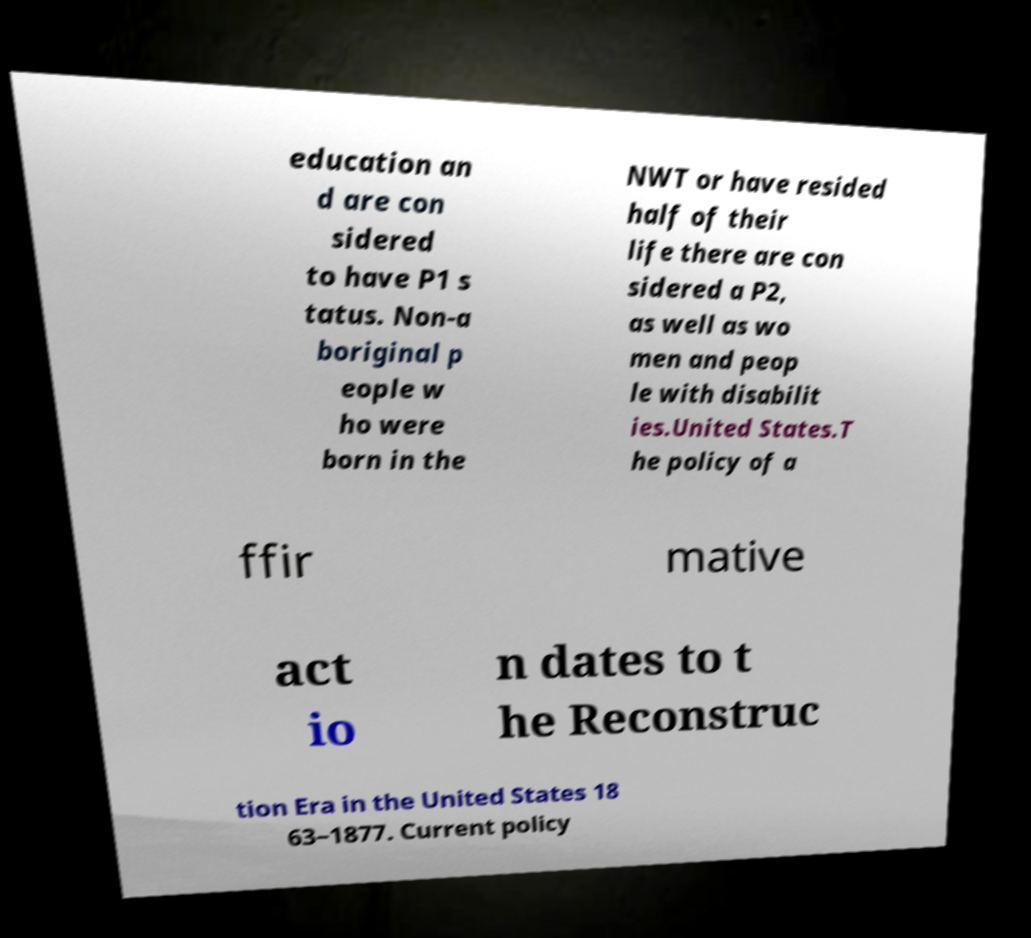Can you read and provide the text displayed in the image?This photo seems to have some interesting text. Can you extract and type it out for me? education an d are con sidered to have P1 s tatus. Non-a boriginal p eople w ho were born in the NWT or have resided half of their life there are con sidered a P2, as well as wo men and peop le with disabilit ies.United States.T he policy of a ffir mative act io n dates to t he Reconstruc tion Era in the United States 18 63–1877. Current policy 